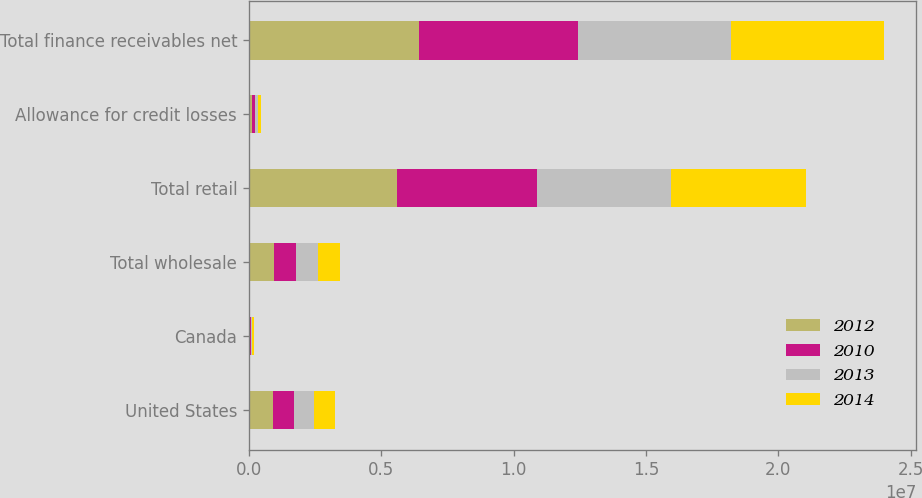<chart> <loc_0><loc_0><loc_500><loc_500><stacked_bar_chart><ecel><fcel>United States<fcel>Canada<fcel>Total wholesale<fcel>Total retail<fcel>Allowance for credit losses<fcel>Total finance receivables net<nl><fcel>2012<fcel>903380<fcel>48941<fcel>952321<fcel>5.60792e+06<fcel>127364<fcel>6.43288e+06<nl><fcel>2010<fcel>800491<fcel>44721<fcel>845212<fcel>5.26504e+06<fcel>110693<fcel>5.99956e+06<nl><fcel>2013<fcel>776633<fcel>39771<fcel>816404<fcel>5.07312e+06<fcel>107667<fcel>5.78185e+06<nl><fcel>2014<fcel>778320<fcel>46320<fcel>824640<fcel>5.08749e+06<fcel>125449<fcel>5.78668e+06<nl></chart> 